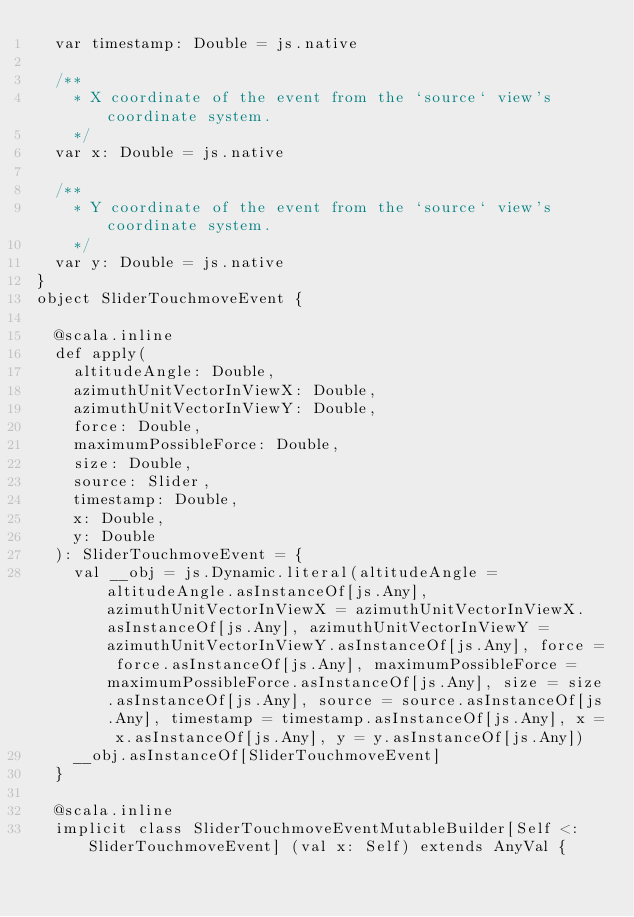Convert code to text. <code><loc_0><loc_0><loc_500><loc_500><_Scala_>  var timestamp: Double = js.native
  
  /**
    * X coordinate of the event from the `source` view's coordinate system.
    */
  var x: Double = js.native
  
  /**
    * Y coordinate of the event from the `source` view's coordinate system.
    */
  var y: Double = js.native
}
object SliderTouchmoveEvent {
  
  @scala.inline
  def apply(
    altitudeAngle: Double,
    azimuthUnitVectorInViewX: Double,
    azimuthUnitVectorInViewY: Double,
    force: Double,
    maximumPossibleForce: Double,
    size: Double,
    source: Slider,
    timestamp: Double,
    x: Double,
    y: Double
  ): SliderTouchmoveEvent = {
    val __obj = js.Dynamic.literal(altitudeAngle = altitudeAngle.asInstanceOf[js.Any], azimuthUnitVectorInViewX = azimuthUnitVectorInViewX.asInstanceOf[js.Any], azimuthUnitVectorInViewY = azimuthUnitVectorInViewY.asInstanceOf[js.Any], force = force.asInstanceOf[js.Any], maximumPossibleForce = maximumPossibleForce.asInstanceOf[js.Any], size = size.asInstanceOf[js.Any], source = source.asInstanceOf[js.Any], timestamp = timestamp.asInstanceOf[js.Any], x = x.asInstanceOf[js.Any], y = y.asInstanceOf[js.Any])
    __obj.asInstanceOf[SliderTouchmoveEvent]
  }
  
  @scala.inline
  implicit class SliderTouchmoveEventMutableBuilder[Self <: SliderTouchmoveEvent] (val x: Self) extends AnyVal {
    </code> 